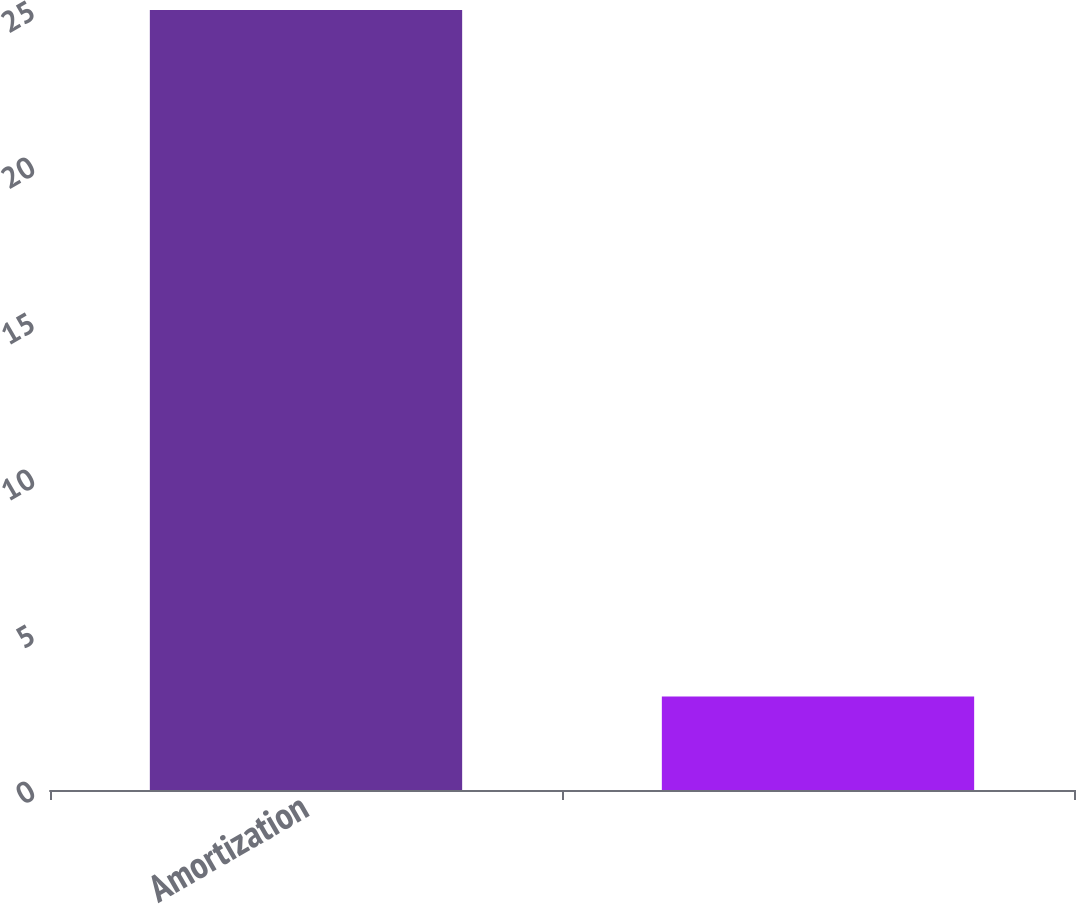<chart> <loc_0><loc_0><loc_500><loc_500><bar_chart><fcel>Amortization<fcel>Unnamed: 1<nl><fcel>25<fcel>3<nl></chart> 